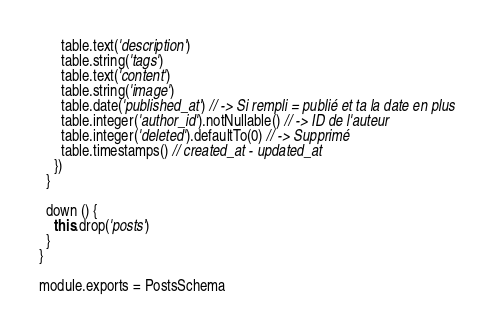Convert code to text. <code><loc_0><loc_0><loc_500><loc_500><_JavaScript_>      table.text('description')
      table.string('tags')
      table.text('content')
      table.string('image')
      table.date('published_at') // -> Si rempli = publié et ta la date en plus
      table.integer('author_id').notNullable() // -> ID de l'auteur
      table.integer('deleted').defaultTo(0) // -> Supprimé
      table.timestamps() // created_at - updated_at
    })
  }

  down () {
    this.drop('posts')
  }
}

module.exports = PostsSchema
</code> 